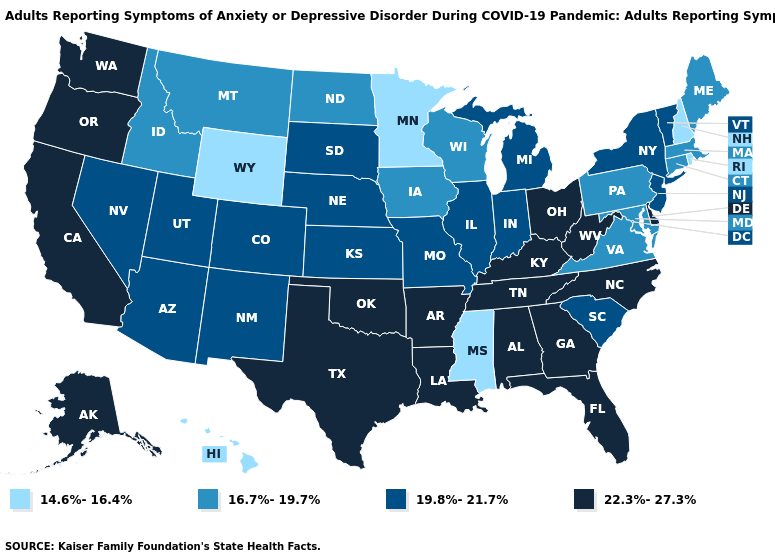Which states have the lowest value in the West?
Write a very short answer. Hawaii, Wyoming. What is the value of West Virginia?
Be succinct. 22.3%-27.3%. What is the lowest value in the USA?
Keep it brief. 14.6%-16.4%. Name the states that have a value in the range 22.3%-27.3%?
Concise answer only. Alabama, Alaska, Arkansas, California, Delaware, Florida, Georgia, Kentucky, Louisiana, North Carolina, Ohio, Oklahoma, Oregon, Tennessee, Texas, Washington, West Virginia. How many symbols are there in the legend?
Keep it brief. 4. How many symbols are there in the legend?
Keep it brief. 4. What is the lowest value in the West?
Answer briefly. 14.6%-16.4%. Name the states that have a value in the range 14.6%-16.4%?
Quick response, please. Hawaii, Minnesota, Mississippi, New Hampshire, Rhode Island, Wyoming. Does Oregon have a lower value than New Mexico?
Short answer required. No. How many symbols are there in the legend?
Concise answer only. 4. Name the states that have a value in the range 14.6%-16.4%?
Answer briefly. Hawaii, Minnesota, Mississippi, New Hampshire, Rhode Island, Wyoming. What is the value of Nebraska?
Be succinct. 19.8%-21.7%. Does the first symbol in the legend represent the smallest category?
Keep it brief. Yes. What is the value of Maine?
Keep it brief. 16.7%-19.7%. What is the value of New Hampshire?
Be succinct. 14.6%-16.4%. 